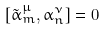<formula> <loc_0><loc_0><loc_500><loc_500>[ \tilde { \alpha } ^ { \mu } _ { m } , \alpha ^ { \nu } _ { n } ] = 0</formula> 